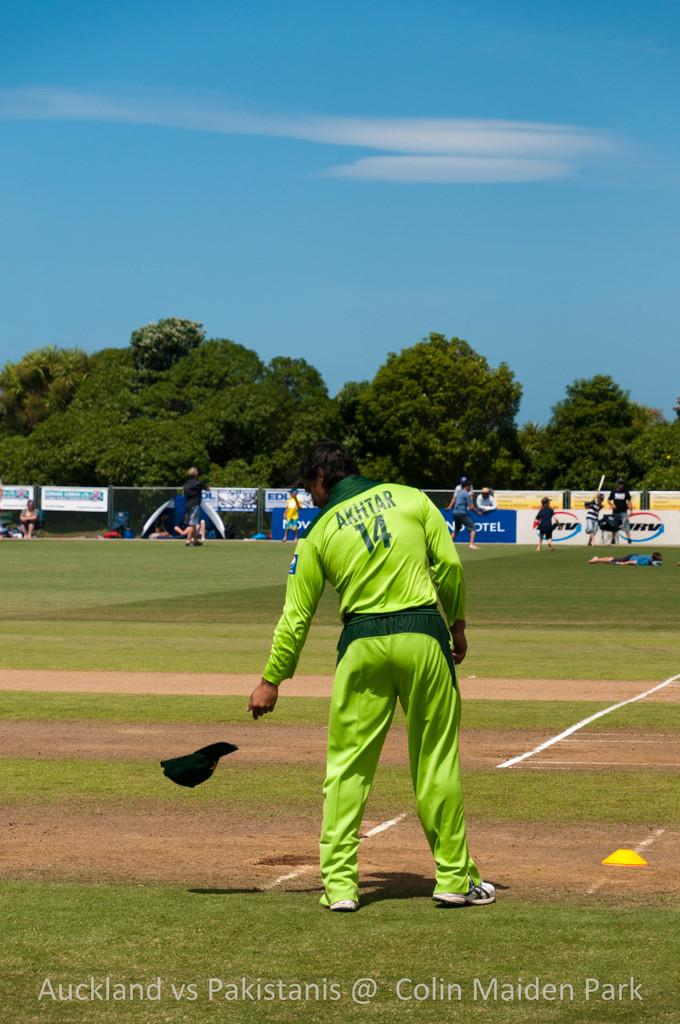<image>
Create a compact narrative representing the image presented. AKHTAR in the number 14 uniform stands on the field during the Auckland vs Pakistanis game at Colin Maiden Park. 